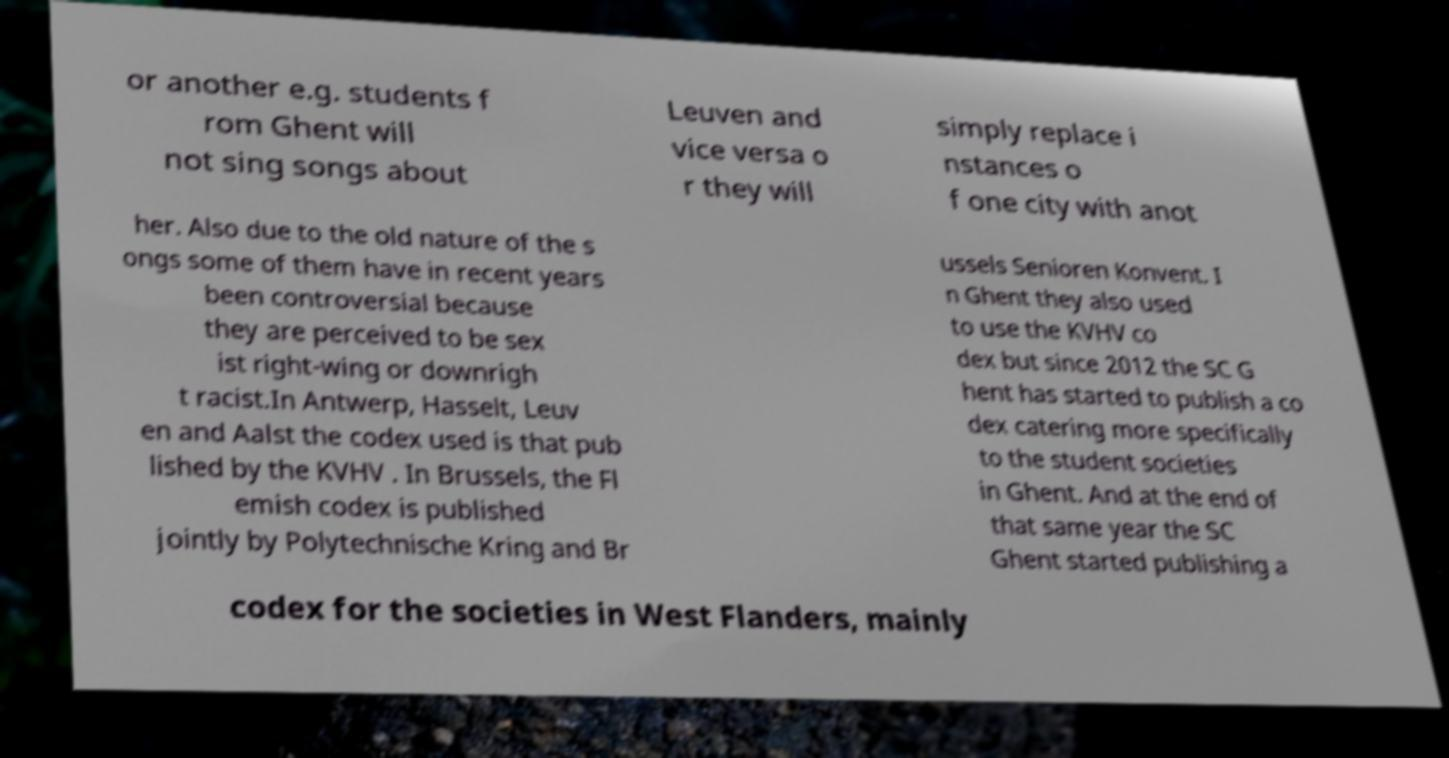Please read and relay the text visible in this image. What does it say? or another e.g. students f rom Ghent will not sing songs about Leuven and vice versa o r they will simply replace i nstances o f one city with anot her. Also due to the old nature of the s ongs some of them have in recent years been controversial because they are perceived to be sex ist right-wing or downrigh t racist.In Antwerp, Hasselt, Leuv en and Aalst the codex used is that pub lished by the KVHV . In Brussels, the Fl emish codex is published jointly by Polytechnische Kring and Br ussels Senioren Konvent. I n Ghent they also used to use the KVHV co dex but since 2012 the SC G hent has started to publish a co dex catering more specifically to the student societies in Ghent. And at the end of that same year the SC Ghent started publishing a codex for the societies in West Flanders, mainly 